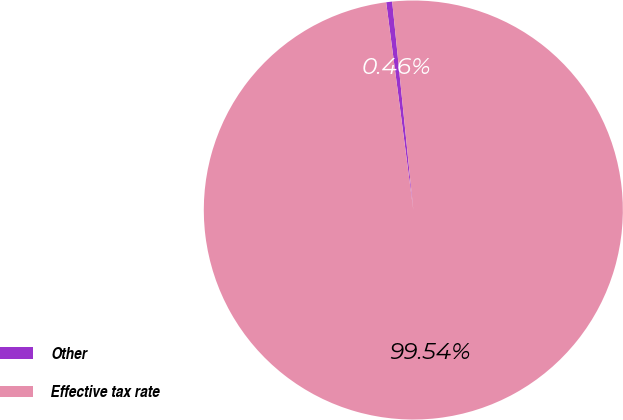Convert chart to OTSL. <chart><loc_0><loc_0><loc_500><loc_500><pie_chart><fcel>Other<fcel>Effective tax rate<nl><fcel>0.46%<fcel>99.54%<nl></chart> 